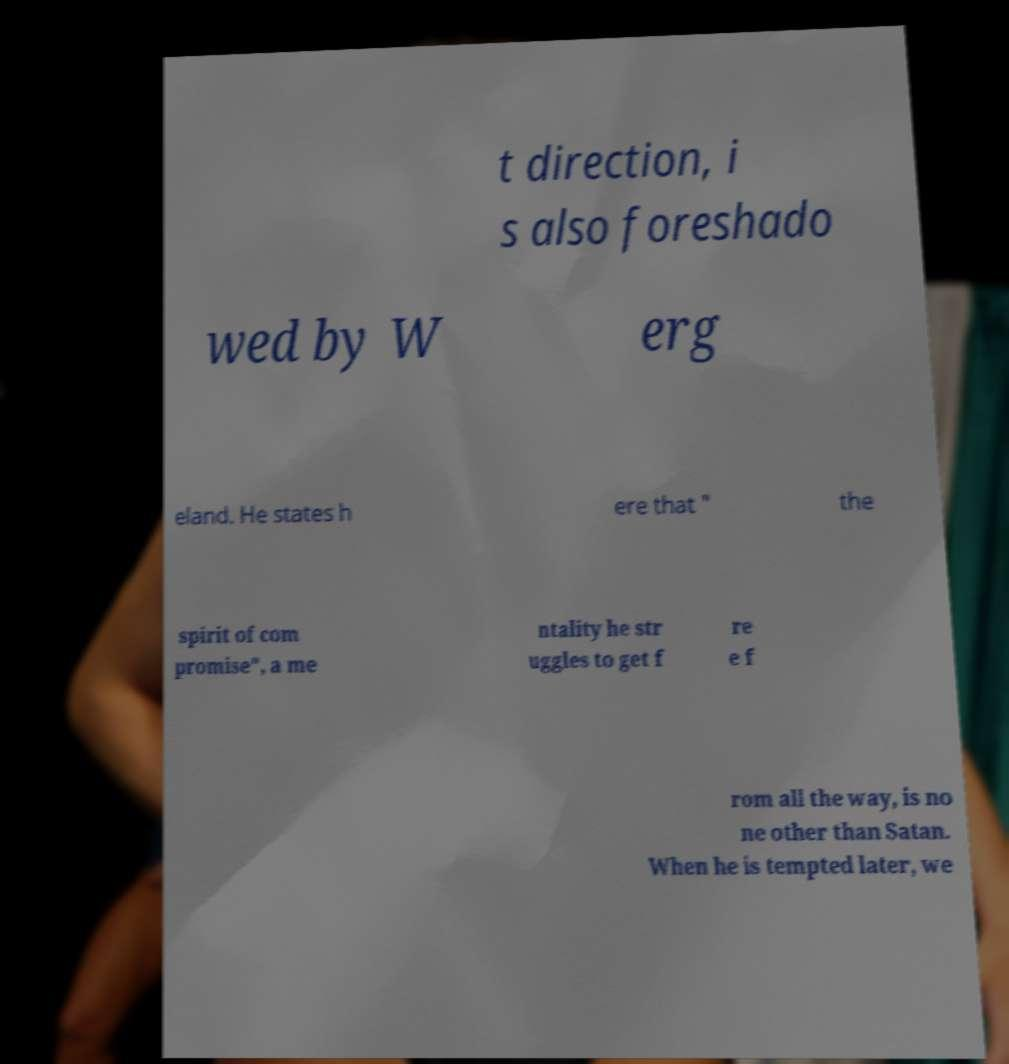I need the written content from this picture converted into text. Can you do that? t direction, i s also foreshado wed by W erg eland. He states h ere that " the spirit of com promise", a me ntality he str uggles to get f re e f rom all the way, is no ne other than Satan. When he is tempted later, we 